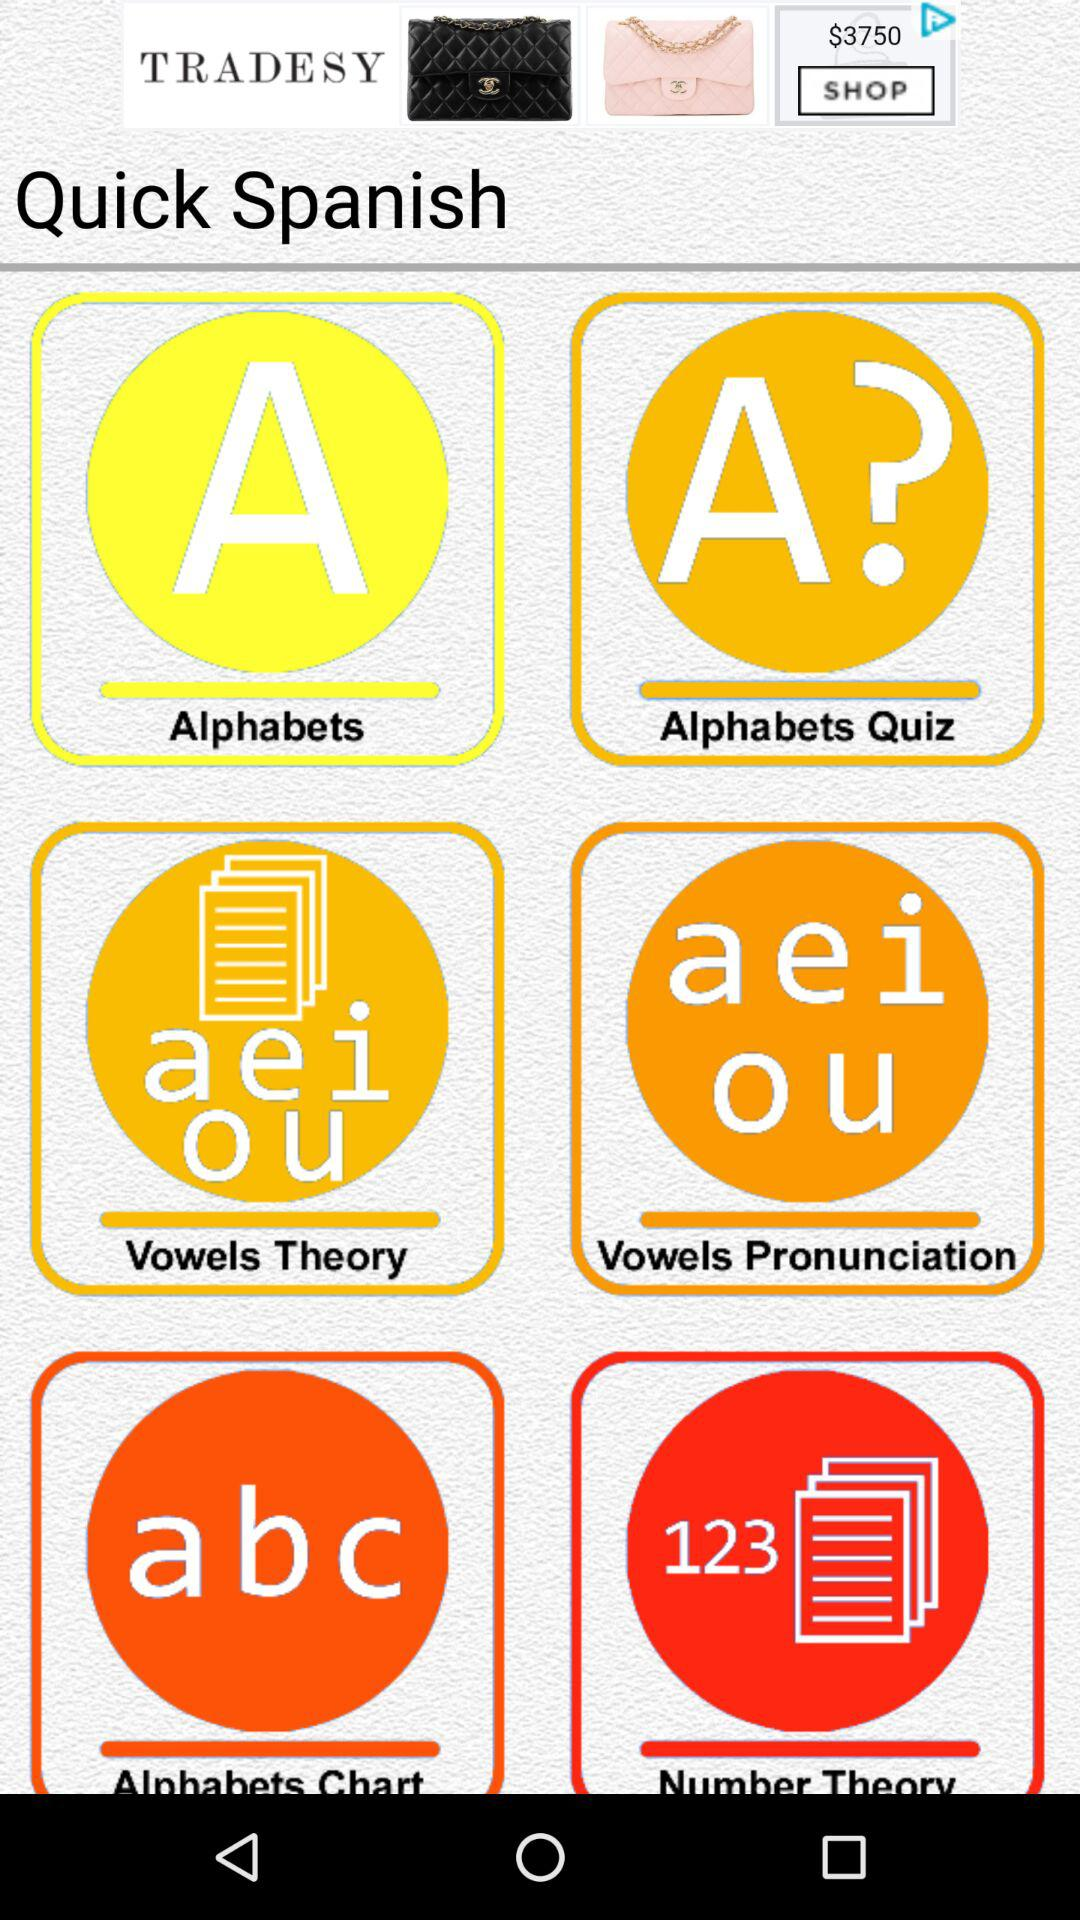What is the name of the application? The application name is "Quick Spanish". 